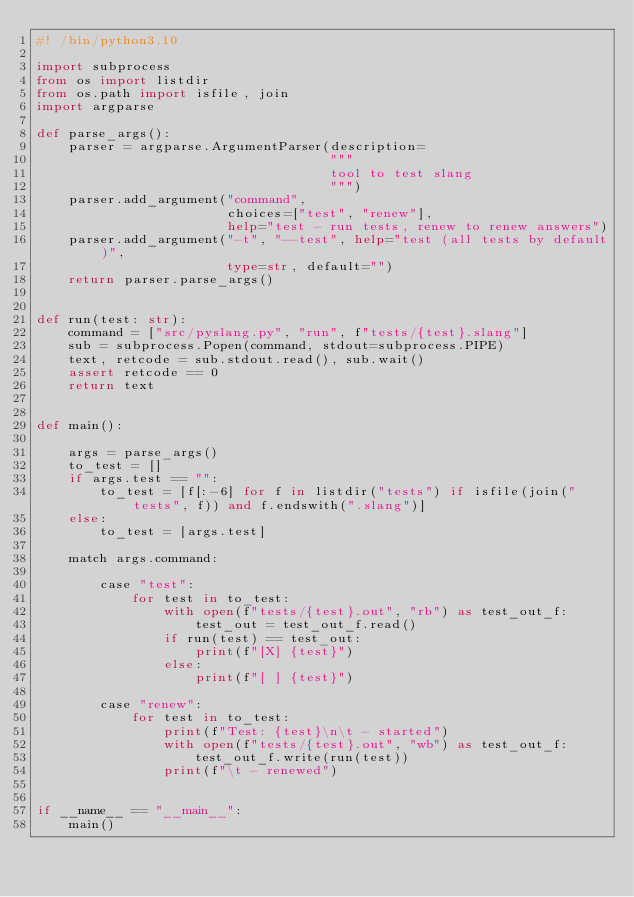<code> <loc_0><loc_0><loc_500><loc_500><_Python_>#! /bin/python3.10

import subprocess
from os import listdir
from os.path import isfile, join
import argparse

def parse_args():
    parser = argparse.ArgumentParser(description=
                                     """
                                     tool to test slang
                                     """)
    parser.add_argument("command",
                        choices=["test", "renew"],
                        help="test - run tests, renew to renew answers")
    parser.add_argument("-t", "--test", help="test (all tests by default)",
                        type=str, default="")
    return parser.parse_args()


def run(test: str):
    command = ["src/pyslang.py", "run", f"tests/{test}.slang"]
    sub = subprocess.Popen(command, stdout=subprocess.PIPE)
    text, retcode = sub.stdout.read(), sub.wait()
    assert retcode == 0
    return text


def main():

    args = parse_args()
    to_test = []
    if args.test == "":
        to_test = [f[:-6] for f in listdir("tests") if isfile(join("tests", f)) and f.endswith(".slang")]
    else:
        to_test = [args.test]

    match args.command:

        case "test":
            for test in to_test:
                with open(f"tests/{test}.out", "rb") as test_out_f:
                    test_out = test_out_f.read()
                if run(test) == test_out:
                    print(f"[X] {test}")
                else:
                    print(f"[ ] {test}")

        case "renew":
            for test in to_test:
                print(f"Test: {test}\n\t - started")
                with open(f"tests/{test}.out", "wb") as test_out_f:
                    test_out_f.write(run(test))
                print(f"\t - renewed")


if __name__ == "__main__":
    main()
</code> 